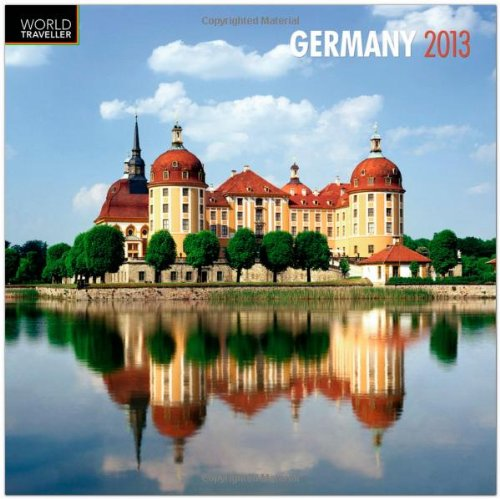What kind of architectural style is represented by the building in this calendar image? The building showcased in the calendar image appears to exhibit features of Baroque architecture, known for its grandiosity, opulent details, and bold structures. 